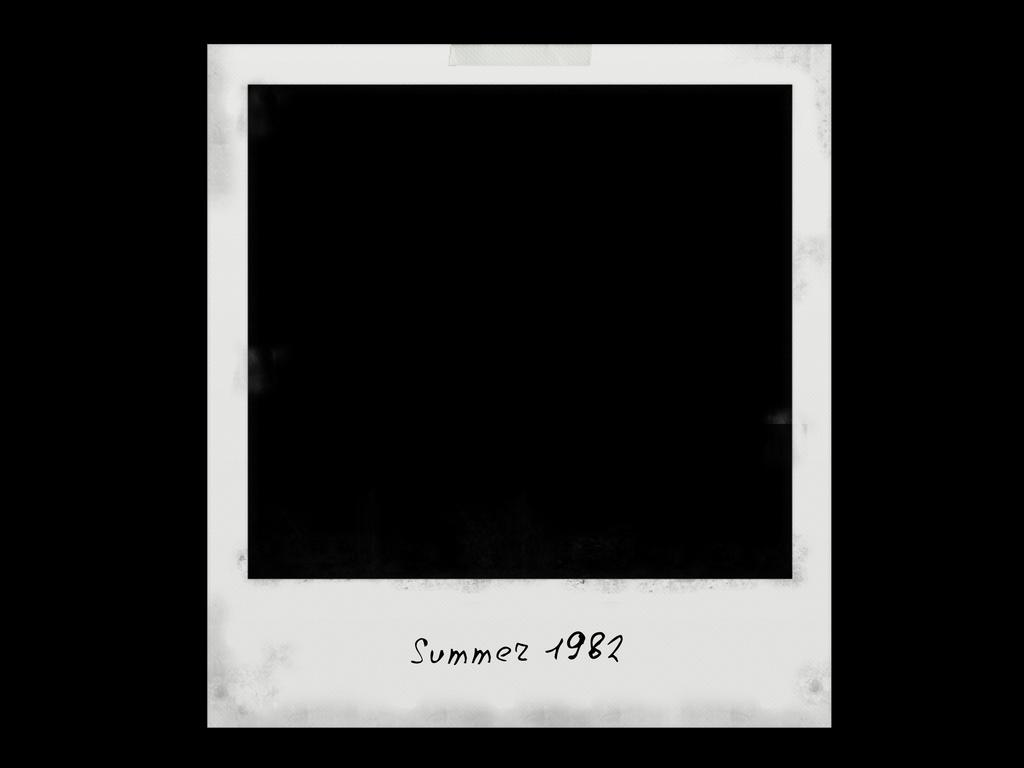What is the main subject of the image? The main subject of the image is a blank photograph. What color is the border around the photograph? The border around the photograph is white. What color is the background of the image? The background of the image is black. How much debt does the person in the field owe to the manager in the image? There is no person, field, or manager present in the image; it contains a blank photograph with a white border and a black background. 